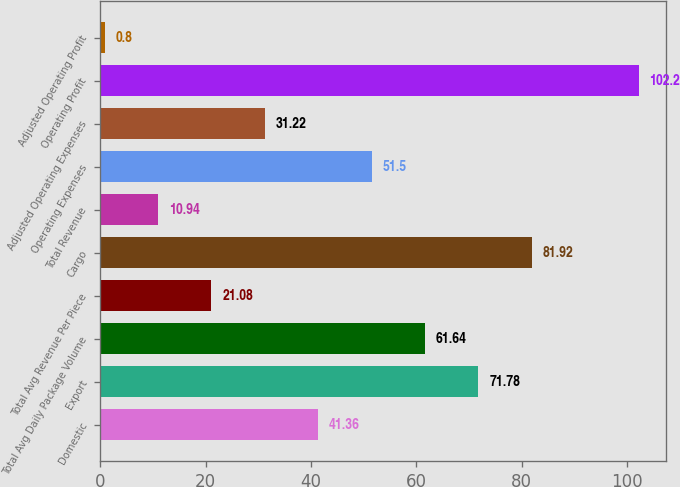Convert chart. <chart><loc_0><loc_0><loc_500><loc_500><bar_chart><fcel>Domestic<fcel>Export<fcel>Total Avg Daily Package Volume<fcel>Total Avg Revenue Per Piece<fcel>Cargo<fcel>Total Revenue<fcel>Operating Expenses<fcel>Adjusted Operating Expenses<fcel>Operating Profit<fcel>Adjusted Operating Profit<nl><fcel>41.36<fcel>71.78<fcel>61.64<fcel>21.08<fcel>81.92<fcel>10.94<fcel>51.5<fcel>31.22<fcel>102.2<fcel>0.8<nl></chart> 